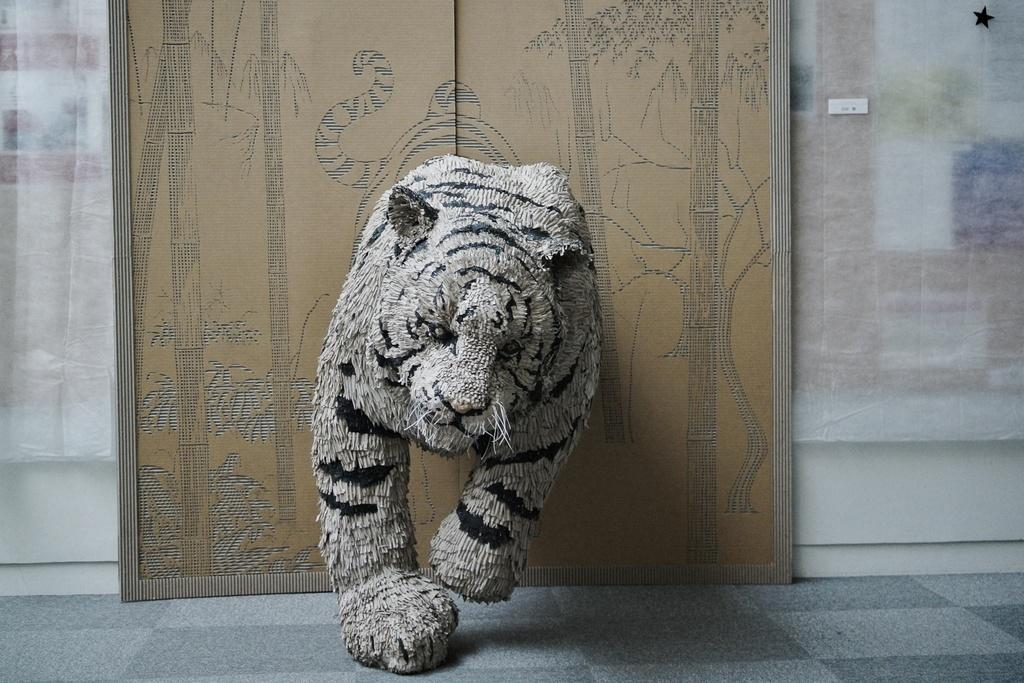What type of animal is depicted in the image using cloth? There is a replica of a tiger made of cloth in the image. What can be seen on the right side of the image? There is a curtain and a wall on the right side of the image. What can be seen on the left side of the image? There is a curtain and a wall on the left side of the image. What type of bean is present in the image? There is no bean present in the image. How does the brake function in the image? There is no brake present in the image. 